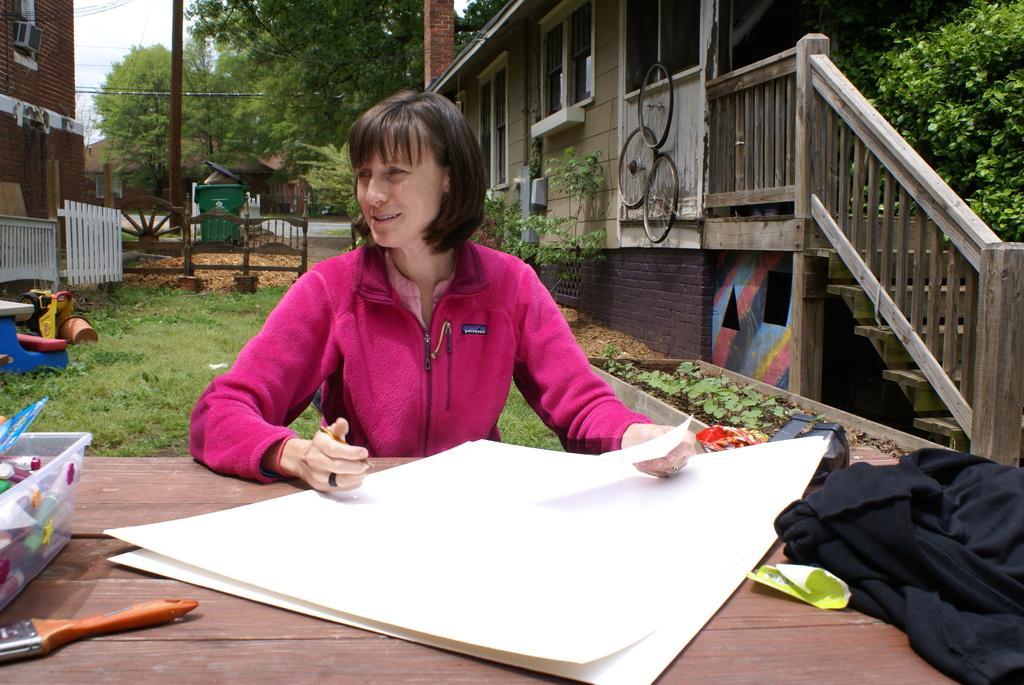How would you summarize this image in a sentence or two? In the middle of the image a woman is sitting and holding a pen and paper. in front of her there table on the table there is a chart. Bottom right side of the image there is a cloth. Behind her there is a grass and fencing. Top left side of the image there is a building and there are some trees. Top right side of the image there is a building and steps beside the building there are few plants. In the middle of the image there is a pole. 